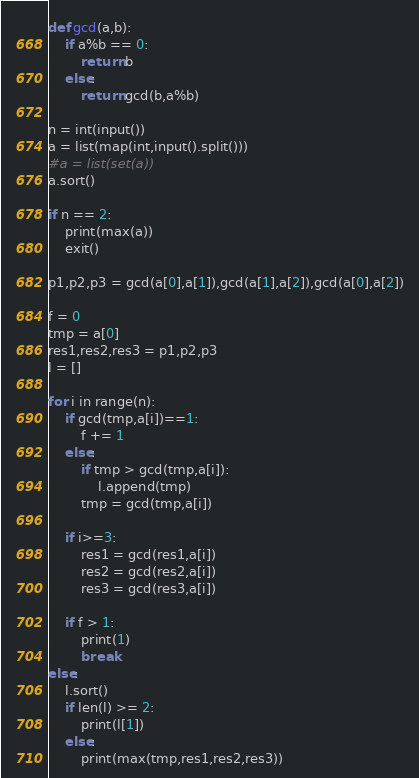<code> <loc_0><loc_0><loc_500><loc_500><_Python_>def gcd(a,b):
    if a%b == 0:
        return b
    else:
        return gcd(b,a%b)

n = int(input())
a = list(map(int,input().split()))
#a = list(set(a))
a.sort()

if n == 2:
    print(max(a))
    exit()

p1,p2,p3 = gcd(a[0],a[1]),gcd(a[1],a[2]),gcd(a[0],a[2])

f = 0
tmp = a[0]
res1,res2,res3 = p1,p2,p3
l = []

for i in range(n):
    if gcd(tmp,a[i])==1:
        f += 1
    else:
        if tmp > gcd(tmp,a[i]):
            l.append(tmp)
        tmp = gcd(tmp,a[i])

    if i>=3:
        res1 = gcd(res1,a[i])
        res2 = gcd(res2,a[i])
        res3 = gcd(res3,a[i])

    if f > 1:
        print(1)
        break
else:
    l.sort()
    if len(l) >= 2:
        print(l[1])
    else:
        print(max(tmp,res1,res2,res3))
</code> 